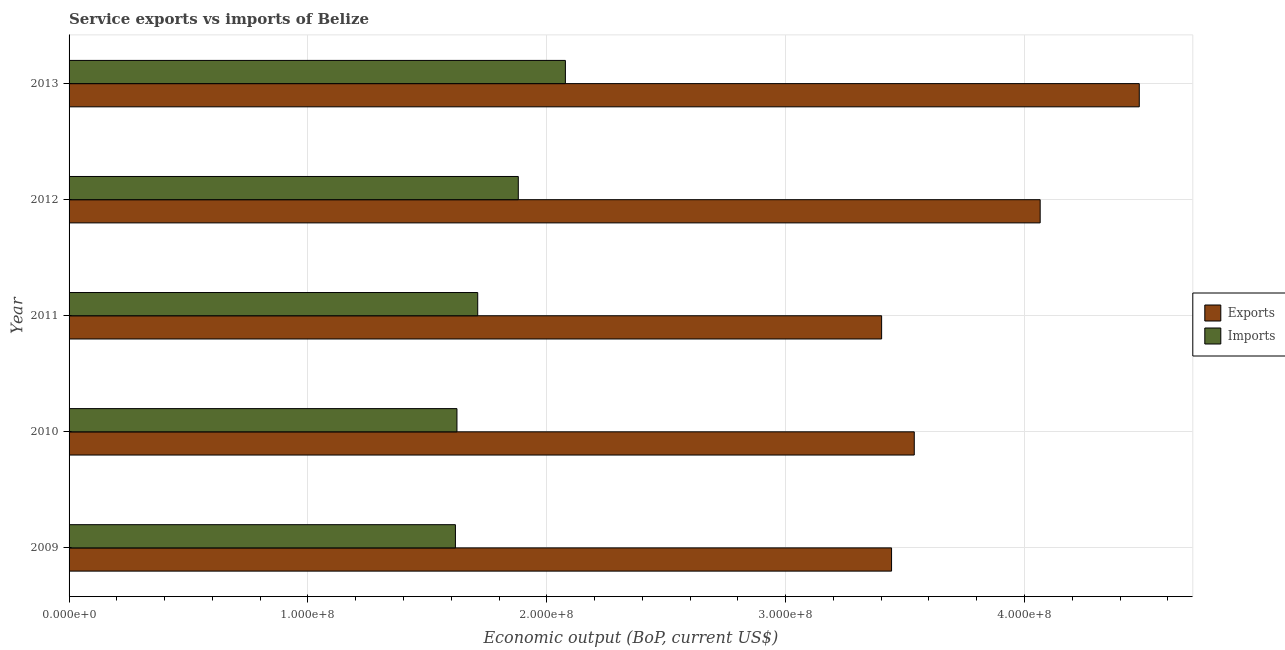How many different coloured bars are there?
Provide a succinct answer. 2. Are the number of bars per tick equal to the number of legend labels?
Offer a terse response. Yes. How many bars are there on the 1st tick from the bottom?
Offer a very short reply. 2. In how many cases, is the number of bars for a given year not equal to the number of legend labels?
Ensure brevity in your answer.  0. What is the amount of service imports in 2009?
Offer a very short reply. 1.62e+08. Across all years, what is the maximum amount of service imports?
Offer a terse response. 2.08e+08. Across all years, what is the minimum amount of service exports?
Your answer should be compact. 3.40e+08. In which year was the amount of service imports minimum?
Your answer should be compact. 2009. What is the total amount of service exports in the graph?
Your answer should be compact. 1.89e+09. What is the difference between the amount of service exports in 2012 and that in 2013?
Make the answer very short. -4.15e+07. What is the difference between the amount of service exports in 2011 and the amount of service imports in 2013?
Your response must be concise. 1.32e+08. What is the average amount of service exports per year?
Offer a very short reply. 3.79e+08. In the year 2009, what is the difference between the amount of service exports and amount of service imports?
Keep it short and to the point. 1.83e+08. In how many years, is the amount of service exports greater than 440000000 US$?
Your response must be concise. 1. What is the ratio of the amount of service exports in 2009 to that in 2012?
Make the answer very short. 0.85. Is the difference between the amount of service imports in 2010 and 2011 greater than the difference between the amount of service exports in 2010 and 2011?
Keep it short and to the point. No. What is the difference between the highest and the second highest amount of service exports?
Your response must be concise. 4.15e+07. What is the difference between the highest and the lowest amount of service imports?
Provide a short and direct response. 4.60e+07. What does the 2nd bar from the top in 2010 represents?
Your response must be concise. Exports. What does the 1st bar from the bottom in 2011 represents?
Ensure brevity in your answer.  Exports. How many bars are there?
Your answer should be compact. 10. Are the values on the major ticks of X-axis written in scientific E-notation?
Provide a succinct answer. Yes. Does the graph contain any zero values?
Make the answer very short. No. Where does the legend appear in the graph?
Offer a terse response. Center right. How are the legend labels stacked?
Provide a succinct answer. Vertical. What is the title of the graph?
Provide a succinct answer. Service exports vs imports of Belize. What is the label or title of the X-axis?
Ensure brevity in your answer.  Economic output (BoP, current US$). What is the label or title of the Y-axis?
Your answer should be very brief. Year. What is the Economic output (BoP, current US$) in Exports in 2009?
Give a very brief answer. 3.44e+08. What is the Economic output (BoP, current US$) in Imports in 2009?
Offer a very short reply. 1.62e+08. What is the Economic output (BoP, current US$) in Exports in 2010?
Provide a short and direct response. 3.54e+08. What is the Economic output (BoP, current US$) in Imports in 2010?
Your answer should be compact. 1.62e+08. What is the Economic output (BoP, current US$) of Exports in 2011?
Your response must be concise. 3.40e+08. What is the Economic output (BoP, current US$) of Imports in 2011?
Offer a terse response. 1.71e+08. What is the Economic output (BoP, current US$) in Exports in 2012?
Provide a succinct answer. 4.07e+08. What is the Economic output (BoP, current US$) of Imports in 2012?
Your answer should be compact. 1.88e+08. What is the Economic output (BoP, current US$) in Exports in 2013?
Keep it short and to the point. 4.48e+08. What is the Economic output (BoP, current US$) of Imports in 2013?
Keep it short and to the point. 2.08e+08. Across all years, what is the maximum Economic output (BoP, current US$) of Exports?
Give a very brief answer. 4.48e+08. Across all years, what is the maximum Economic output (BoP, current US$) of Imports?
Give a very brief answer. 2.08e+08. Across all years, what is the minimum Economic output (BoP, current US$) in Exports?
Give a very brief answer. 3.40e+08. Across all years, what is the minimum Economic output (BoP, current US$) of Imports?
Your answer should be very brief. 1.62e+08. What is the total Economic output (BoP, current US$) of Exports in the graph?
Provide a succinct answer. 1.89e+09. What is the total Economic output (BoP, current US$) in Imports in the graph?
Give a very brief answer. 8.91e+08. What is the difference between the Economic output (BoP, current US$) of Exports in 2009 and that in 2010?
Give a very brief answer. -9.50e+06. What is the difference between the Economic output (BoP, current US$) in Imports in 2009 and that in 2010?
Make the answer very short. -6.44e+05. What is the difference between the Economic output (BoP, current US$) in Exports in 2009 and that in 2011?
Provide a succinct answer. 4.16e+06. What is the difference between the Economic output (BoP, current US$) in Imports in 2009 and that in 2011?
Provide a short and direct response. -9.34e+06. What is the difference between the Economic output (BoP, current US$) in Exports in 2009 and that in 2012?
Keep it short and to the point. -6.22e+07. What is the difference between the Economic output (BoP, current US$) in Imports in 2009 and that in 2012?
Provide a short and direct response. -2.63e+07. What is the difference between the Economic output (BoP, current US$) in Exports in 2009 and that in 2013?
Offer a terse response. -1.04e+08. What is the difference between the Economic output (BoP, current US$) of Imports in 2009 and that in 2013?
Keep it short and to the point. -4.60e+07. What is the difference between the Economic output (BoP, current US$) of Exports in 2010 and that in 2011?
Ensure brevity in your answer.  1.37e+07. What is the difference between the Economic output (BoP, current US$) in Imports in 2010 and that in 2011?
Make the answer very short. -8.69e+06. What is the difference between the Economic output (BoP, current US$) of Exports in 2010 and that in 2012?
Give a very brief answer. -5.27e+07. What is the difference between the Economic output (BoP, current US$) in Imports in 2010 and that in 2012?
Your answer should be very brief. -2.57e+07. What is the difference between the Economic output (BoP, current US$) of Exports in 2010 and that in 2013?
Ensure brevity in your answer.  -9.42e+07. What is the difference between the Economic output (BoP, current US$) in Imports in 2010 and that in 2013?
Make the answer very short. -4.54e+07. What is the difference between the Economic output (BoP, current US$) in Exports in 2011 and that in 2012?
Provide a short and direct response. -6.64e+07. What is the difference between the Economic output (BoP, current US$) of Imports in 2011 and that in 2012?
Make the answer very short. -1.70e+07. What is the difference between the Economic output (BoP, current US$) of Exports in 2011 and that in 2013?
Offer a terse response. -1.08e+08. What is the difference between the Economic output (BoP, current US$) in Imports in 2011 and that in 2013?
Your answer should be very brief. -3.67e+07. What is the difference between the Economic output (BoP, current US$) of Exports in 2012 and that in 2013?
Your response must be concise. -4.15e+07. What is the difference between the Economic output (BoP, current US$) in Imports in 2012 and that in 2013?
Your answer should be very brief. -1.97e+07. What is the difference between the Economic output (BoP, current US$) in Exports in 2009 and the Economic output (BoP, current US$) in Imports in 2010?
Keep it short and to the point. 1.82e+08. What is the difference between the Economic output (BoP, current US$) in Exports in 2009 and the Economic output (BoP, current US$) in Imports in 2011?
Offer a terse response. 1.73e+08. What is the difference between the Economic output (BoP, current US$) of Exports in 2009 and the Economic output (BoP, current US$) of Imports in 2012?
Make the answer very short. 1.56e+08. What is the difference between the Economic output (BoP, current US$) in Exports in 2009 and the Economic output (BoP, current US$) in Imports in 2013?
Provide a succinct answer. 1.37e+08. What is the difference between the Economic output (BoP, current US$) of Exports in 2010 and the Economic output (BoP, current US$) of Imports in 2011?
Ensure brevity in your answer.  1.83e+08. What is the difference between the Economic output (BoP, current US$) of Exports in 2010 and the Economic output (BoP, current US$) of Imports in 2012?
Give a very brief answer. 1.66e+08. What is the difference between the Economic output (BoP, current US$) in Exports in 2010 and the Economic output (BoP, current US$) in Imports in 2013?
Your answer should be very brief. 1.46e+08. What is the difference between the Economic output (BoP, current US$) in Exports in 2011 and the Economic output (BoP, current US$) in Imports in 2012?
Your response must be concise. 1.52e+08. What is the difference between the Economic output (BoP, current US$) in Exports in 2011 and the Economic output (BoP, current US$) in Imports in 2013?
Your response must be concise. 1.32e+08. What is the difference between the Economic output (BoP, current US$) in Exports in 2012 and the Economic output (BoP, current US$) in Imports in 2013?
Offer a very short reply. 1.99e+08. What is the average Economic output (BoP, current US$) of Exports per year?
Offer a terse response. 3.79e+08. What is the average Economic output (BoP, current US$) in Imports per year?
Keep it short and to the point. 1.78e+08. In the year 2009, what is the difference between the Economic output (BoP, current US$) of Exports and Economic output (BoP, current US$) of Imports?
Your answer should be very brief. 1.83e+08. In the year 2010, what is the difference between the Economic output (BoP, current US$) of Exports and Economic output (BoP, current US$) of Imports?
Offer a terse response. 1.91e+08. In the year 2011, what is the difference between the Economic output (BoP, current US$) of Exports and Economic output (BoP, current US$) of Imports?
Offer a very short reply. 1.69e+08. In the year 2012, what is the difference between the Economic output (BoP, current US$) in Exports and Economic output (BoP, current US$) in Imports?
Give a very brief answer. 2.18e+08. In the year 2013, what is the difference between the Economic output (BoP, current US$) of Exports and Economic output (BoP, current US$) of Imports?
Give a very brief answer. 2.40e+08. What is the ratio of the Economic output (BoP, current US$) in Exports in 2009 to that in 2010?
Keep it short and to the point. 0.97. What is the ratio of the Economic output (BoP, current US$) of Imports in 2009 to that in 2010?
Give a very brief answer. 1. What is the ratio of the Economic output (BoP, current US$) in Exports in 2009 to that in 2011?
Your answer should be very brief. 1.01. What is the ratio of the Economic output (BoP, current US$) in Imports in 2009 to that in 2011?
Give a very brief answer. 0.95. What is the ratio of the Economic output (BoP, current US$) of Exports in 2009 to that in 2012?
Offer a terse response. 0.85. What is the ratio of the Economic output (BoP, current US$) of Imports in 2009 to that in 2012?
Offer a very short reply. 0.86. What is the ratio of the Economic output (BoP, current US$) of Exports in 2009 to that in 2013?
Your answer should be very brief. 0.77. What is the ratio of the Economic output (BoP, current US$) of Imports in 2009 to that in 2013?
Your answer should be very brief. 0.78. What is the ratio of the Economic output (BoP, current US$) of Exports in 2010 to that in 2011?
Offer a terse response. 1.04. What is the ratio of the Economic output (BoP, current US$) of Imports in 2010 to that in 2011?
Make the answer very short. 0.95. What is the ratio of the Economic output (BoP, current US$) in Exports in 2010 to that in 2012?
Offer a very short reply. 0.87. What is the ratio of the Economic output (BoP, current US$) in Imports in 2010 to that in 2012?
Your answer should be compact. 0.86. What is the ratio of the Economic output (BoP, current US$) in Exports in 2010 to that in 2013?
Offer a terse response. 0.79. What is the ratio of the Economic output (BoP, current US$) of Imports in 2010 to that in 2013?
Your answer should be compact. 0.78. What is the ratio of the Economic output (BoP, current US$) of Exports in 2011 to that in 2012?
Give a very brief answer. 0.84. What is the ratio of the Economic output (BoP, current US$) of Imports in 2011 to that in 2012?
Offer a terse response. 0.91. What is the ratio of the Economic output (BoP, current US$) in Exports in 2011 to that in 2013?
Your response must be concise. 0.76. What is the ratio of the Economic output (BoP, current US$) in Imports in 2011 to that in 2013?
Provide a short and direct response. 0.82. What is the ratio of the Economic output (BoP, current US$) of Exports in 2012 to that in 2013?
Your response must be concise. 0.91. What is the ratio of the Economic output (BoP, current US$) of Imports in 2012 to that in 2013?
Give a very brief answer. 0.91. What is the difference between the highest and the second highest Economic output (BoP, current US$) in Exports?
Your answer should be very brief. 4.15e+07. What is the difference between the highest and the second highest Economic output (BoP, current US$) of Imports?
Give a very brief answer. 1.97e+07. What is the difference between the highest and the lowest Economic output (BoP, current US$) in Exports?
Offer a terse response. 1.08e+08. What is the difference between the highest and the lowest Economic output (BoP, current US$) of Imports?
Make the answer very short. 4.60e+07. 